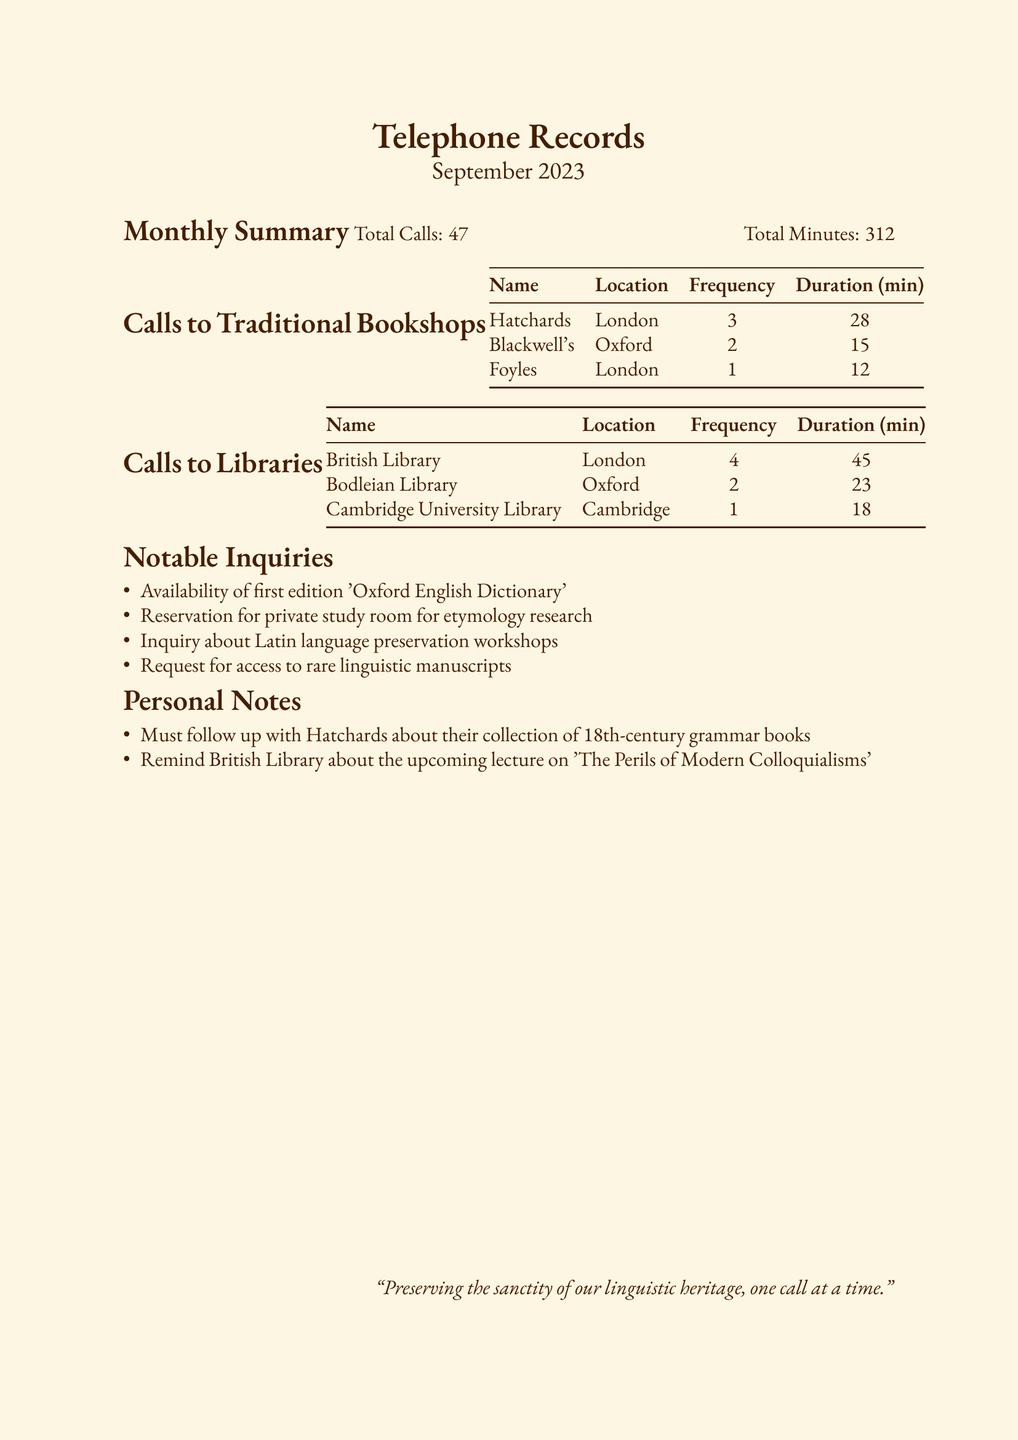What is the total number of calls made? The total number of calls is explicitly stated in the summary section, which lists a total of 47 calls.
Answer: 47 How many minutes were spent on phone calls? The total minutes spent on calls is also provided in the summary section, which notes a total of 312 minutes.
Answer: 312 Which bookshop in London received the most calls? The name and frequency of calls to each bookshop is listed, showing that Hatchards received 3 calls, the most among them.
Answer: Hatchards What was the duration of calls made to the British Library? The duration is specified in the table for calls to libraries, indicating that 45 minutes were spent on calls to the British Library.
Answer: 45 How many times was the Bodleian Library called? The frequency of calls to the Bodleian Library is listed in the library calls table, which indicates 2 calls were made.
Answer: 2 What notable inquiry was made regarding manuscripts? The section on notable inquiries lists a request about access to rare linguistic manuscripts, highlighting a specific interest.
Answer: Rare linguistic manuscripts What personal note relates to Hatchards? One of the personal notes indicates a follow-up with Hatchards about their collection of 18th-century grammar books, providing specific context.
Answer: 18th-century grammar books How many calls were listed in the calls to libraries section? The number of calls can be determined by counting the entries in the libraries table, which includes three libraries.
Answer: 3 What topic will the upcoming lecture at the British Library cover? The personal notes mention an upcoming lecture on 'The Perils of Modern Colloquialisms,' providing insight into the planned discussion.
Answer: The Perils of Modern Colloquialisms 